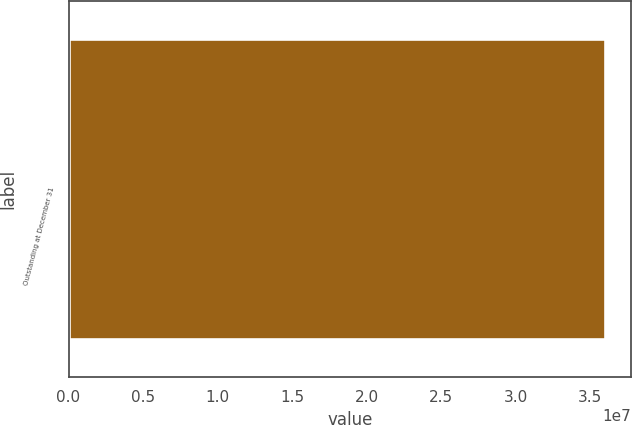Convert chart to OTSL. <chart><loc_0><loc_0><loc_500><loc_500><bar_chart><fcel>Outstanding at December 31<nl><fcel>3.59827e+07<nl></chart> 